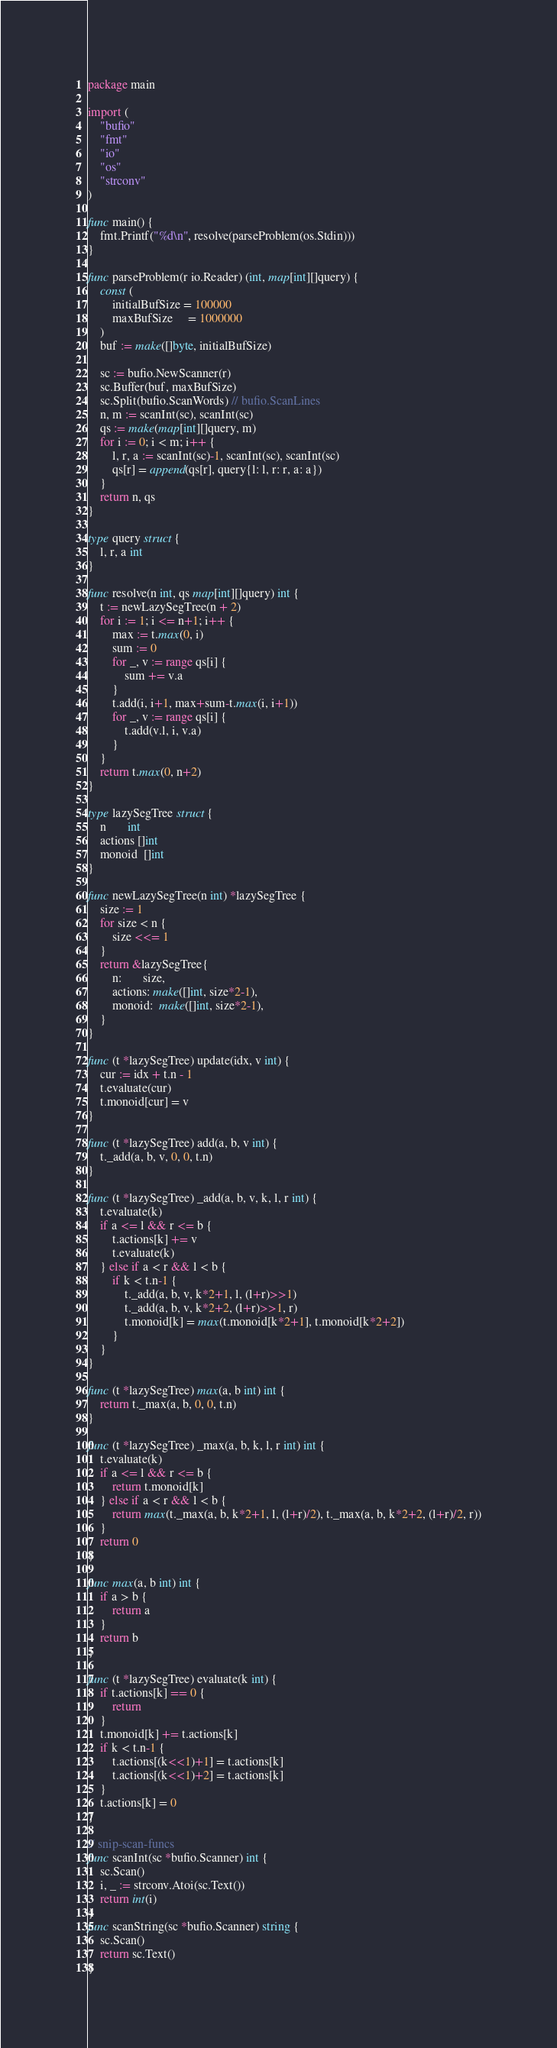Convert code to text. <code><loc_0><loc_0><loc_500><loc_500><_Go_>package main

import (
	"bufio"
	"fmt"
	"io"
	"os"
	"strconv"
)

func main() {
	fmt.Printf("%d\n", resolve(parseProblem(os.Stdin)))
}

func parseProblem(r io.Reader) (int, map[int][]query) {
	const (
		initialBufSize = 100000
		maxBufSize     = 1000000
	)
	buf := make([]byte, initialBufSize)

	sc := bufio.NewScanner(r)
	sc.Buffer(buf, maxBufSize)
	sc.Split(bufio.ScanWords) // bufio.ScanLines
	n, m := scanInt(sc), scanInt(sc)
	qs := make(map[int][]query, m)
	for i := 0; i < m; i++ {
		l, r, a := scanInt(sc)-1, scanInt(sc), scanInt(sc)
		qs[r] = append(qs[r], query{l: l, r: r, a: a})
	}
	return n, qs
}

type query struct {
	l, r, a int
}

func resolve(n int, qs map[int][]query) int {
	t := newLazySegTree(n + 2)
	for i := 1; i <= n+1; i++ {
		max := t.max(0, i)
		sum := 0
		for _, v := range qs[i] {
			sum += v.a
		}
		t.add(i, i+1, max+sum-t.max(i, i+1))
		for _, v := range qs[i] {
			t.add(v.l, i, v.a)
		}
	}
	return t.max(0, n+2)
}

type lazySegTree struct {
	n       int
	actions []int
	monoid  []int
}

func newLazySegTree(n int) *lazySegTree {
	size := 1
	for size < n {
		size <<= 1
	}
	return &lazySegTree{
		n:       size,
		actions: make([]int, size*2-1),
		monoid:  make([]int, size*2-1),
	}
}

func (t *lazySegTree) update(idx, v int) {
	cur := idx + t.n - 1
	t.evaluate(cur)
	t.monoid[cur] = v
}

func (t *lazySegTree) add(a, b, v int) {
	t._add(a, b, v, 0, 0, t.n)
}

func (t *lazySegTree) _add(a, b, v, k, l, r int) {
	t.evaluate(k)
	if a <= l && r <= b {
		t.actions[k] += v
		t.evaluate(k)
	} else if a < r && l < b {
		if k < t.n-1 {
			t._add(a, b, v, k*2+1, l, (l+r)>>1)
			t._add(a, b, v, k*2+2, (l+r)>>1, r)
			t.monoid[k] = max(t.monoid[k*2+1], t.monoid[k*2+2])
		}
	}
}

func (t *lazySegTree) max(a, b int) int {
	return t._max(a, b, 0, 0, t.n)
}

func (t *lazySegTree) _max(a, b, k, l, r int) int {
	t.evaluate(k)
	if a <= l && r <= b {
		return t.monoid[k]
	} else if a < r && l < b {
		return max(t._max(a, b, k*2+1, l, (l+r)/2), t._max(a, b, k*2+2, (l+r)/2, r))
	}
	return 0
}

func max(a, b int) int {
	if a > b {
		return a
	}
	return b
}

func (t *lazySegTree) evaluate(k int) {
	if t.actions[k] == 0 {
		return
	}
	t.monoid[k] += t.actions[k]
	if k < t.n-1 {
		t.actions[(k<<1)+1] = t.actions[k]
		t.actions[(k<<1)+2] = t.actions[k]
	}
	t.actions[k] = 0
}

// snip-scan-funcs
func scanInt(sc *bufio.Scanner) int {
	sc.Scan()
	i, _ := strconv.Atoi(sc.Text())
	return int(i)
}
func scanString(sc *bufio.Scanner) string {
	sc.Scan()
	return sc.Text()
}
</code> 